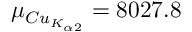<formula> <loc_0><loc_0><loc_500><loc_500>\mu _ { C u _ { K _ { \alpha 2 } } } = 8 0 2 7 . 8</formula> 